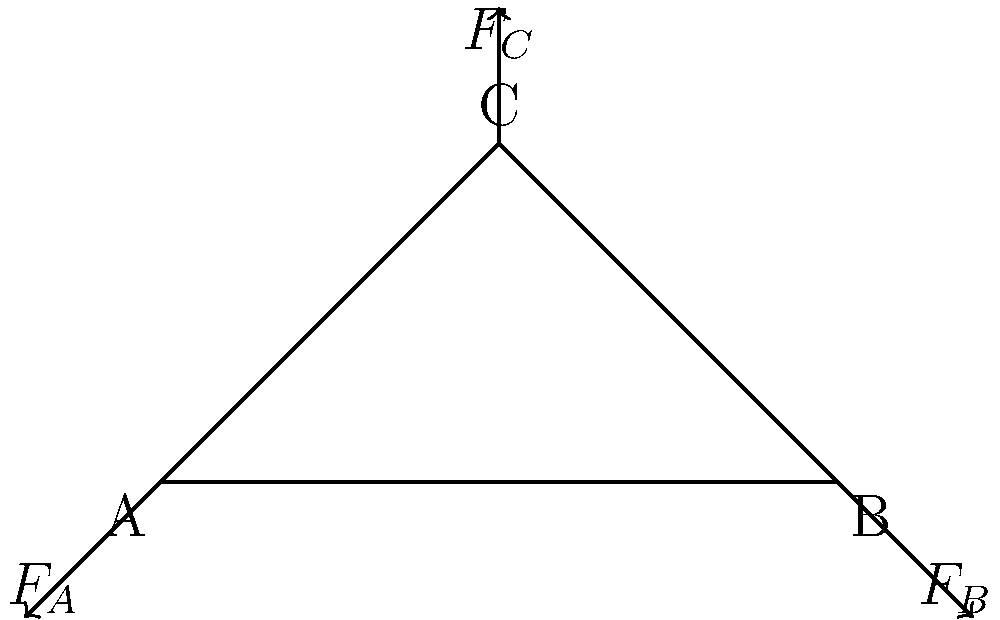As an entrepreneurial student who values work-life balance, consider a simple truss bridge structure as shown. If the vertical force $F_C$ at point C is 100 kN, and the structure is in equilibrium, determine the magnitude of the reaction forces $F_A$ and $F_B$ at points A and B, respectively. To solve this problem, we'll use the principles of static equilibrium, which relate to balancing work and life. Let's break it down step-by-step:

1) For a structure in equilibrium, the sum of all forces must equal zero.

2) We have two equations of equilibrium:
   - Sum of horizontal forces: $\sum F_x = 0$
   - Sum of vertical forces: $\sum F_y = 0$

3) From the vertical force equation:
   $F_A + F_B - F_C = 0$
   $F_A + F_B = 100$ kN (1)

4) For the horizontal forces, $F_A$ and $F_B$ must be equal and opposite to maintain equilibrium:
   $F_{Ax} = F_{Bx}$ (2)

5) Given the symmetry of the structure, we can deduce that $F_A = F_B$

6) Substituting this into equation (1):
   $F_A + F_A = 100$ kN
   $2F_A = 100$ kN

7) Solving for $F_A$:
   $F_A = 50$ kN

8) Since $F_A = F_B$, we know that $F_B$ is also 50 kN.

This balanced solution reflects the importance of equilibrium in both engineering and life management.
Answer: $F_A = F_B = 50$ kN 